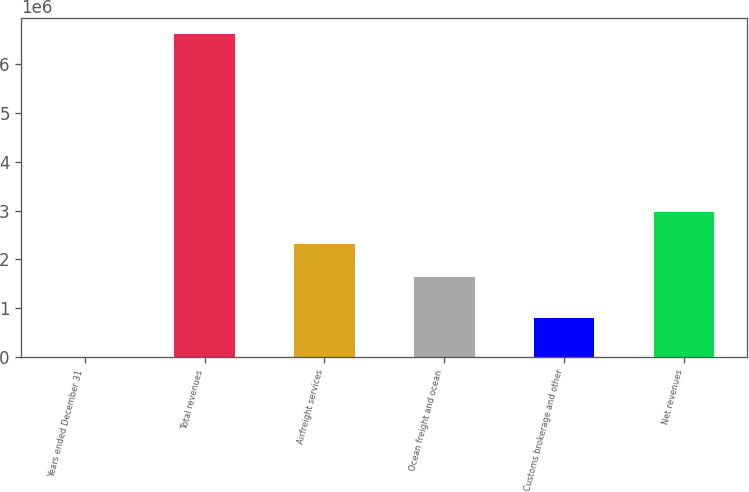Convert chart to OTSL. <chart><loc_0><loc_0><loc_500><loc_500><bar_chart><fcel>Years ended December 31<fcel>Total revenues<fcel>Airfreight services<fcel>Ocean freight and ocean<fcel>Customs brokerage and other<fcel>Net revenues<nl><fcel>2015<fcel>6.61663e+06<fcel>2.31045e+06<fcel>1.64899e+06<fcel>792172<fcel>2.97192e+06<nl></chart> 